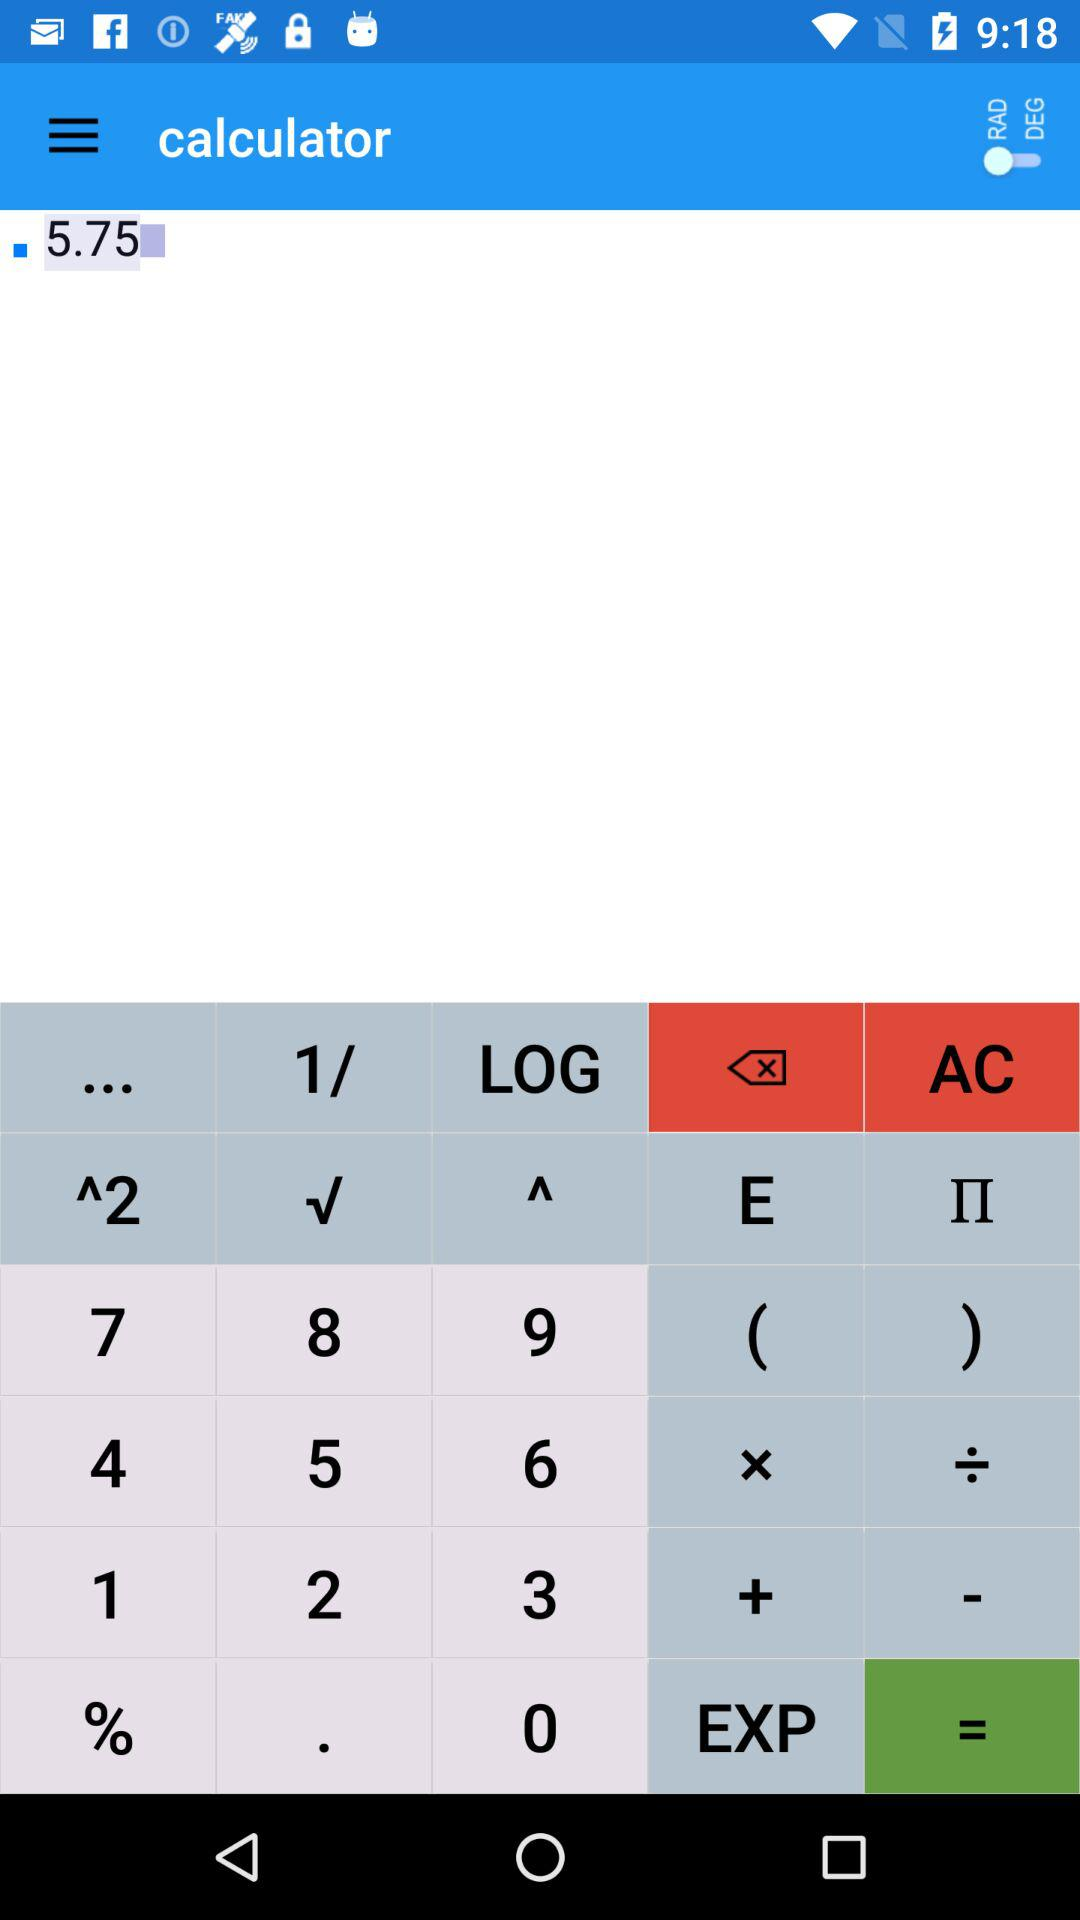What is the application name? The application name is "calculator". 